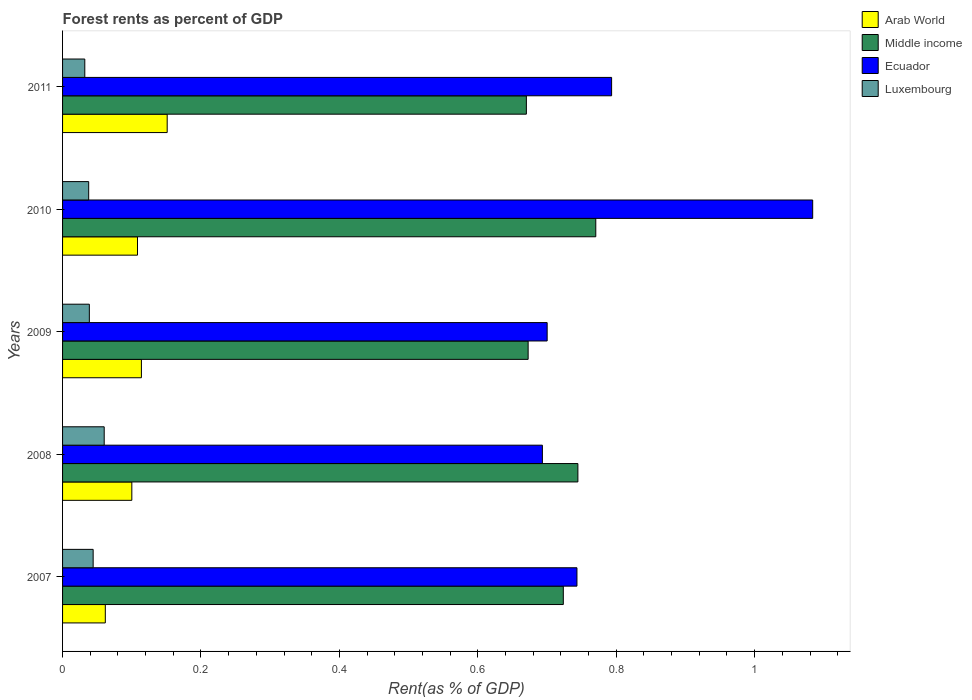How many different coloured bars are there?
Keep it short and to the point. 4. How many groups of bars are there?
Provide a short and direct response. 5. What is the label of the 4th group of bars from the top?
Provide a short and direct response. 2008. In how many cases, is the number of bars for a given year not equal to the number of legend labels?
Offer a very short reply. 0. What is the forest rent in Luxembourg in 2011?
Keep it short and to the point. 0.03. Across all years, what is the maximum forest rent in Middle income?
Your answer should be compact. 0.77. Across all years, what is the minimum forest rent in Arab World?
Provide a short and direct response. 0.06. In which year was the forest rent in Middle income maximum?
Provide a succinct answer. 2010. What is the total forest rent in Luxembourg in the graph?
Provide a succinct answer. 0.21. What is the difference between the forest rent in Luxembourg in 2007 and that in 2010?
Keep it short and to the point. 0.01. What is the difference between the forest rent in Arab World in 2009 and the forest rent in Luxembourg in 2008?
Ensure brevity in your answer.  0.05. What is the average forest rent in Arab World per year?
Your answer should be very brief. 0.11. In the year 2009, what is the difference between the forest rent in Middle income and forest rent in Luxembourg?
Offer a very short reply. 0.63. What is the ratio of the forest rent in Luxembourg in 2007 to that in 2009?
Your answer should be compact. 1.14. Is the forest rent in Ecuador in 2008 less than that in 2009?
Provide a short and direct response. Yes. What is the difference between the highest and the second highest forest rent in Ecuador?
Offer a very short reply. 0.29. What is the difference between the highest and the lowest forest rent in Luxembourg?
Give a very brief answer. 0.03. Is it the case that in every year, the sum of the forest rent in Ecuador and forest rent in Luxembourg is greater than the sum of forest rent in Arab World and forest rent in Middle income?
Give a very brief answer. Yes. What does the 4th bar from the top in 2008 represents?
Your answer should be very brief. Arab World. What does the 4th bar from the bottom in 2007 represents?
Give a very brief answer. Luxembourg. Does the graph contain any zero values?
Provide a short and direct response. No. Does the graph contain grids?
Give a very brief answer. No. What is the title of the graph?
Give a very brief answer. Forest rents as percent of GDP. Does "Brunei Darussalam" appear as one of the legend labels in the graph?
Your response must be concise. No. What is the label or title of the X-axis?
Keep it short and to the point. Rent(as % of GDP). What is the label or title of the Y-axis?
Give a very brief answer. Years. What is the Rent(as % of GDP) in Arab World in 2007?
Your response must be concise. 0.06. What is the Rent(as % of GDP) of Middle income in 2007?
Your response must be concise. 0.72. What is the Rent(as % of GDP) of Ecuador in 2007?
Ensure brevity in your answer.  0.74. What is the Rent(as % of GDP) of Luxembourg in 2007?
Your answer should be compact. 0.04. What is the Rent(as % of GDP) of Arab World in 2008?
Your response must be concise. 0.1. What is the Rent(as % of GDP) in Middle income in 2008?
Provide a succinct answer. 0.74. What is the Rent(as % of GDP) in Ecuador in 2008?
Offer a terse response. 0.69. What is the Rent(as % of GDP) in Luxembourg in 2008?
Make the answer very short. 0.06. What is the Rent(as % of GDP) in Arab World in 2009?
Ensure brevity in your answer.  0.11. What is the Rent(as % of GDP) of Middle income in 2009?
Your answer should be compact. 0.67. What is the Rent(as % of GDP) in Ecuador in 2009?
Make the answer very short. 0.7. What is the Rent(as % of GDP) in Luxembourg in 2009?
Give a very brief answer. 0.04. What is the Rent(as % of GDP) of Arab World in 2010?
Offer a terse response. 0.11. What is the Rent(as % of GDP) in Middle income in 2010?
Offer a very short reply. 0.77. What is the Rent(as % of GDP) in Ecuador in 2010?
Provide a short and direct response. 1.08. What is the Rent(as % of GDP) in Luxembourg in 2010?
Your answer should be compact. 0.04. What is the Rent(as % of GDP) of Arab World in 2011?
Your answer should be very brief. 0.15. What is the Rent(as % of GDP) of Middle income in 2011?
Offer a very short reply. 0.67. What is the Rent(as % of GDP) in Ecuador in 2011?
Provide a short and direct response. 0.79. What is the Rent(as % of GDP) of Luxembourg in 2011?
Your answer should be very brief. 0.03. Across all years, what is the maximum Rent(as % of GDP) in Arab World?
Provide a succinct answer. 0.15. Across all years, what is the maximum Rent(as % of GDP) in Middle income?
Offer a terse response. 0.77. Across all years, what is the maximum Rent(as % of GDP) in Ecuador?
Offer a very short reply. 1.08. Across all years, what is the maximum Rent(as % of GDP) of Luxembourg?
Provide a short and direct response. 0.06. Across all years, what is the minimum Rent(as % of GDP) in Arab World?
Make the answer very short. 0.06. Across all years, what is the minimum Rent(as % of GDP) in Middle income?
Your answer should be compact. 0.67. Across all years, what is the minimum Rent(as % of GDP) of Ecuador?
Give a very brief answer. 0.69. Across all years, what is the minimum Rent(as % of GDP) in Luxembourg?
Your response must be concise. 0.03. What is the total Rent(as % of GDP) in Arab World in the graph?
Provide a short and direct response. 0.54. What is the total Rent(as % of GDP) in Middle income in the graph?
Provide a succinct answer. 3.58. What is the total Rent(as % of GDP) of Ecuador in the graph?
Provide a succinct answer. 4.01. What is the total Rent(as % of GDP) in Luxembourg in the graph?
Keep it short and to the point. 0.21. What is the difference between the Rent(as % of GDP) of Arab World in 2007 and that in 2008?
Make the answer very short. -0.04. What is the difference between the Rent(as % of GDP) in Middle income in 2007 and that in 2008?
Offer a terse response. -0.02. What is the difference between the Rent(as % of GDP) in Ecuador in 2007 and that in 2008?
Your answer should be very brief. 0.05. What is the difference between the Rent(as % of GDP) of Luxembourg in 2007 and that in 2008?
Keep it short and to the point. -0.02. What is the difference between the Rent(as % of GDP) of Arab World in 2007 and that in 2009?
Keep it short and to the point. -0.05. What is the difference between the Rent(as % of GDP) of Middle income in 2007 and that in 2009?
Provide a succinct answer. 0.05. What is the difference between the Rent(as % of GDP) in Ecuador in 2007 and that in 2009?
Your response must be concise. 0.04. What is the difference between the Rent(as % of GDP) in Luxembourg in 2007 and that in 2009?
Offer a very short reply. 0.01. What is the difference between the Rent(as % of GDP) of Arab World in 2007 and that in 2010?
Keep it short and to the point. -0.05. What is the difference between the Rent(as % of GDP) in Middle income in 2007 and that in 2010?
Ensure brevity in your answer.  -0.05. What is the difference between the Rent(as % of GDP) of Ecuador in 2007 and that in 2010?
Ensure brevity in your answer.  -0.34. What is the difference between the Rent(as % of GDP) of Luxembourg in 2007 and that in 2010?
Ensure brevity in your answer.  0.01. What is the difference between the Rent(as % of GDP) in Arab World in 2007 and that in 2011?
Ensure brevity in your answer.  -0.09. What is the difference between the Rent(as % of GDP) of Middle income in 2007 and that in 2011?
Offer a terse response. 0.05. What is the difference between the Rent(as % of GDP) in Ecuador in 2007 and that in 2011?
Keep it short and to the point. -0.05. What is the difference between the Rent(as % of GDP) of Luxembourg in 2007 and that in 2011?
Ensure brevity in your answer.  0.01. What is the difference between the Rent(as % of GDP) in Arab World in 2008 and that in 2009?
Offer a very short reply. -0.01. What is the difference between the Rent(as % of GDP) of Middle income in 2008 and that in 2009?
Provide a short and direct response. 0.07. What is the difference between the Rent(as % of GDP) in Ecuador in 2008 and that in 2009?
Provide a short and direct response. -0.01. What is the difference between the Rent(as % of GDP) of Luxembourg in 2008 and that in 2009?
Make the answer very short. 0.02. What is the difference between the Rent(as % of GDP) in Arab World in 2008 and that in 2010?
Your answer should be compact. -0.01. What is the difference between the Rent(as % of GDP) in Middle income in 2008 and that in 2010?
Offer a very short reply. -0.03. What is the difference between the Rent(as % of GDP) of Ecuador in 2008 and that in 2010?
Your answer should be compact. -0.39. What is the difference between the Rent(as % of GDP) of Luxembourg in 2008 and that in 2010?
Your answer should be very brief. 0.02. What is the difference between the Rent(as % of GDP) in Arab World in 2008 and that in 2011?
Provide a succinct answer. -0.05. What is the difference between the Rent(as % of GDP) in Middle income in 2008 and that in 2011?
Your answer should be very brief. 0.07. What is the difference between the Rent(as % of GDP) in Luxembourg in 2008 and that in 2011?
Ensure brevity in your answer.  0.03. What is the difference between the Rent(as % of GDP) in Arab World in 2009 and that in 2010?
Your answer should be very brief. 0.01. What is the difference between the Rent(as % of GDP) in Middle income in 2009 and that in 2010?
Your response must be concise. -0.1. What is the difference between the Rent(as % of GDP) in Ecuador in 2009 and that in 2010?
Keep it short and to the point. -0.38. What is the difference between the Rent(as % of GDP) of Luxembourg in 2009 and that in 2010?
Give a very brief answer. 0. What is the difference between the Rent(as % of GDP) of Arab World in 2009 and that in 2011?
Offer a terse response. -0.04. What is the difference between the Rent(as % of GDP) in Middle income in 2009 and that in 2011?
Ensure brevity in your answer.  0. What is the difference between the Rent(as % of GDP) of Ecuador in 2009 and that in 2011?
Offer a terse response. -0.09. What is the difference between the Rent(as % of GDP) of Luxembourg in 2009 and that in 2011?
Provide a short and direct response. 0.01. What is the difference between the Rent(as % of GDP) of Arab World in 2010 and that in 2011?
Keep it short and to the point. -0.04. What is the difference between the Rent(as % of GDP) in Middle income in 2010 and that in 2011?
Your answer should be very brief. 0.1. What is the difference between the Rent(as % of GDP) of Ecuador in 2010 and that in 2011?
Ensure brevity in your answer.  0.29. What is the difference between the Rent(as % of GDP) in Luxembourg in 2010 and that in 2011?
Your answer should be compact. 0.01. What is the difference between the Rent(as % of GDP) in Arab World in 2007 and the Rent(as % of GDP) in Middle income in 2008?
Keep it short and to the point. -0.68. What is the difference between the Rent(as % of GDP) in Arab World in 2007 and the Rent(as % of GDP) in Ecuador in 2008?
Your response must be concise. -0.63. What is the difference between the Rent(as % of GDP) in Arab World in 2007 and the Rent(as % of GDP) in Luxembourg in 2008?
Offer a very short reply. 0. What is the difference between the Rent(as % of GDP) in Middle income in 2007 and the Rent(as % of GDP) in Ecuador in 2008?
Provide a succinct answer. 0.03. What is the difference between the Rent(as % of GDP) in Middle income in 2007 and the Rent(as % of GDP) in Luxembourg in 2008?
Your answer should be compact. 0.66. What is the difference between the Rent(as % of GDP) in Ecuador in 2007 and the Rent(as % of GDP) in Luxembourg in 2008?
Provide a short and direct response. 0.68. What is the difference between the Rent(as % of GDP) in Arab World in 2007 and the Rent(as % of GDP) in Middle income in 2009?
Make the answer very short. -0.61. What is the difference between the Rent(as % of GDP) in Arab World in 2007 and the Rent(as % of GDP) in Ecuador in 2009?
Your answer should be very brief. -0.64. What is the difference between the Rent(as % of GDP) of Arab World in 2007 and the Rent(as % of GDP) of Luxembourg in 2009?
Keep it short and to the point. 0.02. What is the difference between the Rent(as % of GDP) in Middle income in 2007 and the Rent(as % of GDP) in Ecuador in 2009?
Make the answer very short. 0.02. What is the difference between the Rent(as % of GDP) in Middle income in 2007 and the Rent(as % of GDP) in Luxembourg in 2009?
Provide a succinct answer. 0.68. What is the difference between the Rent(as % of GDP) of Ecuador in 2007 and the Rent(as % of GDP) of Luxembourg in 2009?
Provide a succinct answer. 0.7. What is the difference between the Rent(as % of GDP) in Arab World in 2007 and the Rent(as % of GDP) in Middle income in 2010?
Your response must be concise. -0.71. What is the difference between the Rent(as % of GDP) in Arab World in 2007 and the Rent(as % of GDP) in Ecuador in 2010?
Make the answer very short. -1.02. What is the difference between the Rent(as % of GDP) in Arab World in 2007 and the Rent(as % of GDP) in Luxembourg in 2010?
Ensure brevity in your answer.  0.02. What is the difference between the Rent(as % of GDP) in Middle income in 2007 and the Rent(as % of GDP) in Ecuador in 2010?
Your response must be concise. -0.36. What is the difference between the Rent(as % of GDP) in Middle income in 2007 and the Rent(as % of GDP) in Luxembourg in 2010?
Offer a terse response. 0.69. What is the difference between the Rent(as % of GDP) in Ecuador in 2007 and the Rent(as % of GDP) in Luxembourg in 2010?
Keep it short and to the point. 0.71. What is the difference between the Rent(as % of GDP) in Arab World in 2007 and the Rent(as % of GDP) in Middle income in 2011?
Provide a succinct answer. -0.61. What is the difference between the Rent(as % of GDP) in Arab World in 2007 and the Rent(as % of GDP) in Ecuador in 2011?
Offer a very short reply. -0.73. What is the difference between the Rent(as % of GDP) of Arab World in 2007 and the Rent(as % of GDP) of Luxembourg in 2011?
Provide a short and direct response. 0.03. What is the difference between the Rent(as % of GDP) of Middle income in 2007 and the Rent(as % of GDP) of Ecuador in 2011?
Give a very brief answer. -0.07. What is the difference between the Rent(as % of GDP) of Middle income in 2007 and the Rent(as % of GDP) of Luxembourg in 2011?
Your answer should be very brief. 0.69. What is the difference between the Rent(as % of GDP) of Ecuador in 2007 and the Rent(as % of GDP) of Luxembourg in 2011?
Offer a terse response. 0.71. What is the difference between the Rent(as % of GDP) in Arab World in 2008 and the Rent(as % of GDP) in Middle income in 2009?
Offer a very short reply. -0.57. What is the difference between the Rent(as % of GDP) of Arab World in 2008 and the Rent(as % of GDP) of Ecuador in 2009?
Provide a succinct answer. -0.6. What is the difference between the Rent(as % of GDP) in Arab World in 2008 and the Rent(as % of GDP) in Luxembourg in 2009?
Make the answer very short. 0.06. What is the difference between the Rent(as % of GDP) in Middle income in 2008 and the Rent(as % of GDP) in Ecuador in 2009?
Offer a terse response. 0.04. What is the difference between the Rent(as % of GDP) of Middle income in 2008 and the Rent(as % of GDP) of Luxembourg in 2009?
Offer a very short reply. 0.71. What is the difference between the Rent(as % of GDP) in Ecuador in 2008 and the Rent(as % of GDP) in Luxembourg in 2009?
Your answer should be very brief. 0.65. What is the difference between the Rent(as % of GDP) in Arab World in 2008 and the Rent(as % of GDP) in Middle income in 2010?
Provide a short and direct response. -0.67. What is the difference between the Rent(as % of GDP) in Arab World in 2008 and the Rent(as % of GDP) in Ecuador in 2010?
Your answer should be very brief. -0.98. What is the difference between the Rent(as % of GDP) in Arab World in 2008 and the Rent(as % of GDP) in Luxembourg in 2010?
Offer a very short reply. 0.06. What is the difference between the Rent(as % of GDP) of Middle income in 2008 and the Rent(as % of GDP) of Ecuador in 2010?
Give a very brief answer. -0.34. What is the difference between the Rent(as % of GDP) of Middle income in 2008 and the Rent(as % of GDP) of Luxembourg in 2010?
Offer a terse response. 0.71. What is the difference between the Rent(as % of GDP) of Ecuador in 2008 and the Rent(as % of GDP) of Luxembourg in 2010?
Ensure brevity in your answer.  0.66. What is the difference between the Rent(as % of GDP) of Arab World in 2008 and the Rent(as % of GDP) of Middle income in 2011?
Keep it short and to the point. -0.57. What is the difference between the Rent(as % of GDP) in Arab World in 2008 and the Rent(as % of GDP) in Ecuador in 2011?
Offer a very short reply. -0.69. What is the difference between the Rent(as % of GDP) in Arab World in 2008 and the Rent(as % of GDP) in Luxembourg in 2011?
Your answer should be compact. 0.07. What is the difference between the Rent(as % of GDP) of Middle income in 2008 and the Rent(as % of GDP) of Ecuador in 2011?
Offer a terse response. -0.05. What is the difference between the Rent(as % of GDP) in Middle income in 2008 and the Rent(as % of GDP) in Luxembourg in 2011?
Offer a very short reply. 0.71. What is the difference between the Rent(as % of GDP) of Ecuador in 2008 and the Rent(as % of GDP) of Luxembourg in 2011?
Make the answer very short. 0.66. What is the difference between the Rent(as % of GDP) of Arab World in 2009 and the Rent(as % of GDP) of Middle income in 2010?
Your response must be concise. -0.66. What is the difference between the Rent(as % of GDP) in Arab World in 2009 and the Rent(as % of GDP) in Ecuador in 2010?
Your answer should be very brief. -0.97. What is the difference between the Rent(as % of GDP) in Arab World in 2009 and the Rent(as % of GDP) in Luxembourg in 2010?
Give a very brief answer. 0.08. What is the difference between the Rent(as % of GDP) in Middle income in 2009 and the Rent(as % of GDP) in Ecuador in 2010?
Keep it short and to the point. -0.41. What is the difference between the Rent(as % of GDP) in Middle income in 2009 and the Rent(as % of GDP) in Luxembourg in 2010?
Provide a succinct answer. 0.63. What is the difference between the Rent(as % of GDP) in Ecuador in 2009 and the Rent(as % of GDP) in Luxembourg in 2010?
Give a very brief answer. 0.66. What is the difference between the Rent(as % of GDP) of Arab World in 2009 and the Rent(as % of GDP) of Middle income in 2011?
Provide a short and direct response. -0.56. What is the difference between the Rent(as % of GDP) of Arab World in 2009 and the Rent(as % of GDP) of Ecuador in 2011?
Offer a terse response. -0.68. What is the difference between the Rent(as % of GDP) in Arab World in 2009 and the Rent(as % of GDP) in Luxembourg in 2011?
Keep it short and to the point. 0.08. What is the difference between the Rent(as % of GDP) in Middle income in 2009 and the Rent(as % of GDP) in Ecuador in 2011?
Keep it short and to the point. -0.12. What is the difference between the Rent(as % of GDP) in Middle income in 2009 and the Rent(as % of GDP) in Luxembourg in 2011?
Offer a terse response. 0.64. What is the difference between the Rent(as % of GDP) in Ecuador in 2009 and the Rent(as % of GDP) in Luxembourg in 2011?
Provide a succinct answer. 0.67. What is the difference between the Rent(as % of GDP) of Arab World in 2010 and the Rent(as % of GDP) of Middle income in 2011?
Offer a terse response. -0.56. What is the difference between the Rent(as % of GDP) of Arab World in 2010 and the Rent(as % of GDP) of Ecuador in 2011?
Provide a short and direct response. -0.69. What is the difference between the Rent(as % of GDP) in Arab World in 2010 and the Rent(as % of GDP) in Luxembourg in 2011?
Offer a terse response. 0.08. What is the difference between the Rent(as % of GDP) of Middle income in 2010 and the Rent(as % of GDP) of Ecuador in 2011?
Make the answer very short. -0.02. What is the difference between the Rent(as % of GDP) of Middle income in 2010 and the Rent(as % of GDP) of Luxembourg in 2011?
Give a very brief answer. 0.74. What is the difference between the Rent(as % of GDP) in Ecuador in 2010 and the Rent(as % of GDP) in Luxembourg in 2011?
Make the answer very short. 1.05. What is the average Rent(as % of GDP) of Arab World per year?
Ensure brevity in your answer.  0.11. What is the average Rent(as % of GDP) in Middle income per year?
Give a very brief answer. 0.72. What is the average Rent(as % of GDP) in Ecuador per year?
Provide a short and direct response. 0.8. What is the average Rent(as % of GDP) in Luxembourg per year?
Ensure brevity in your answer.  0.04. In the year 2007, what is the difference between the Rent(as % of GDP) in Arab World and Rent(as % of GDP) in Middle income?
Your response must be concise. -0.66. In the year 2007, what is the difference between the Rent(as % of GDP) in Arab World and Rent(as % of GDP) in Ecuador?
Your answer should be very brief. -0.68. In the year 2007, what is the difference between the Rent(as % of GDP) of Arab World and Rent(as % of GDP) of Luxembourg?
Give a very brief answer. 0.02. In the year 2007, what is the difference between the Rent(as % of GDP) of Middle income and Rent(as % of GDP) of Ecuador?
Your answer should be compact. -0.02. In the year 2007, what is the difference between the Rent(as % of GDP) of Middle income and Rent(as % of GDP) of Luxembourg?
Your answer should be compact. 0.68. In the year 2007, what is the difference between the Rent(as % of GDP) of Ecuador and Rent(as % of GDP) of Luxembourg?
Your answer should be very brief. 0.7. In the year 2008, what is the difference between the Rent(as % of GDP) in Arab World and Rent(as % of GDP) in Middle income?
Make the answer very short. -0.64. In the year 2008, what is the difference between the Rent(as % of GDP) of Arab World and Rent(as % of GDP) of Ecuador?
Make the answer very short. -0.59. In the year 2008, what is the difference between the Rent(as % of GDP) in Arab World and Rent(as % of GDP) in Luxembourg?
Your answer should be very brief. 0.04. In the year 2008, what is the difference between the Rent(as % of GDP) of Middle income and Rent(as % of GDP) of Ecuador?
Ensure brevity in your answer.  0.05. In the year 2008, what is the difference between the Rent(as % of GDP) in Middle income and Rent(as % of GDP) in Luxembourg?
Your answer should be compact. 0.68. In the year 2008, what is the difference between the Rent(as % of GDP) of Ecuador and Rent(as % of GDP) of Luxembourg?
Ensure brevity in your answer.  0.63. In the year 2009, what is the difference between the Rent(as % of GDP) in Arab World and Rent(as % of GDP) in Middle income?
Provide a short and direct response. -0.56. In the year 2009, what is the difference between the Rent(as % of GDP) in Arab World and Rent(as % of GDP) in Ecuador?
Your answer should be compact. -0.59. In the year 2009, what is the difference between the Rent(as % of GDP) of Arab World and Rent(as % of GDP) of Luxembourg?
Make the answer very short. 0.08. In the year 2009, what is the difference between the Rent(as % of GDP) in Middle income and Rent(as % of GDP) in Ecuador?
Give a very brief answer. -0.03. In the year 2009, what is the difference between the Rent(as % of GDP) in Middle income and Rent(as % of GDP) in Luxembourg?
Give a very brief answer. 0.63. In the year 2009, what is the difference between the Rent(as % of GDP) of Ecuador and Rent(as % of GDP) of Luxembourg?
Your answer should be very brief. 0.66. In the year 2010, what is the difference between the Rent(as % of GDP) of Arab World and Rent(as % of GDP) of Middle income?
Keep it short and to the point. -0.66. In the year 2010, what is the difference between the Rent(as % of GDP) in Arab World and Rent(as % of GDP) in Ecuador?
Keep it short and to the point. -0.98. In the year 2010, what is the difference between the Rent(as % of GDP) in Arab World and Rent(as % of GDP) in Luxembourg?
Provide a succinct answer. 0.07. In the year 2010, what is the difference between the Rent(as % of GDP) in Middle income and Rent(as % of GDP) in Ecuador?
Your response must be concise. -0.31. In the year 2010, what is the difference between the Rent(as % of GDP) in Middle income and Rent(as % of GDP) in Luxembourg?
Make the answer very short. 0.73. In the year 2010, what is the difference between the Rent(as % of GDP) of Ecuador and Rent(as % of GDP) of Luxembourg?
Your answer should be compact. 1.05. In the year 2011, what is the difference between the Rent(as % of GDP) in Arab World and Rent(as % of GDP) in Middle income?
Make the answer very short. -0.52. In the year 2011, what is the difference between the Rent(as % of GDP) of Arab World and Rent(as % of GDP) of Ecuador?
Your answer should be very brief. -0.64. In the year 2011, what is the difference between the Rent(as % of GDP) in Arab World and Rent(as % of GDP) in Luxembourg?
Make the answer very short. 0.12. In the year 2011, what is the difference between the Rent(as % of GDP) in Middle income and Rent(as % of GDP) in Ecuador?
Provide a succinct answer. -0.12. In the year 2011, what is the difference between the Rent(as % of GDP) of Middle income and Rent(as % of GDP) of Luxembourg?
Offer a very short reply. 0.64. In the year 2011, what is the difference between the Rent(as % of GDP) of Ecuador and Rent(as % of GDP) of Luxembourg?
Your answer should be very brief. 0.76. What is the ratio of the Rent(as % of GDP) of Arab World in 2007 to that in 2008?
Your answer should be very brief. 0.62. What is the ratio of the Rent(as % of GDP) of Middle income in 2007 to that in 2008?
Ensure brevity in your answer.  0.97. What is the ratio of the Rent(as % of GDP) in Ecuador in 2007 to that in 2008?
Provide a succinct answer. 1.07. What is the ratio of the Rent(as % of GDP) of Luxembourg in 2007 to that in 2008?
Give a very brief answer. 0.73. What is the ratio of the Rent(as % of GDP) in Arab World in 2007 to that in 2009?
Your answer should be compact. 0.54. What is the ratio of the Rent(as % of GDP) of Middle income in 2007 to that in 2009?
Offer a very short reply. 1.08. What is the ratio of the Rent(as % of GDP) of Ecuador in 2007 to that in 2009?
Keep it short and to the point. 1.06. What is the ratio of the Rent(as % of GDP) of Luxembourg in 2007 to that in 2009?
Your answer should be compact. 1.14. What is the ratio of the Rent(as % of GDP) of Arab World in 2007 to that in 2010?
Ensure brevity in your answer.  0.57. What is the ratio of the Rent(as % of GDP) in Middle income in 2007 to that in 2010?
Provide a short and direct response. 0.94. What is the ratio of the Rent(as % of GDP) of Ecuador in 2007 to that in 2010?
Provide a succinct answer. 0.69. What is the ratio of the Rent(as % of GDP) in Luxembourg in 2007 to that in 2010?
Your answer should be very brief. 1.17. What is the ratio of the Rent(as % of GDP) of Arab World in 2007 to that in 2011?
Offer a very short reply. 0.41. What is the ratio of the Rent(as % of GDP) in Middle income in 2007 to that in 2011?
Your answer should be very brief. 1.08. What is the ratio of the Rent(as % of GDP) of Ecuador in 2007 to that in 2011?
Provide a succinct answer. 0.94. What is the ratio of the Rent(as % of GDP) of Luxembourg in 2007 to that in 2011?
Give a very brief answer. 1.38. What is the ratio of the Rent(as % of GDP) in Arab World in 2008 to that in 2009?
Offer a terse response. 0.88. What is the ratio of the Rent(as % of GDP) in Middle income in 2008 to that in 2009?
Make the answer very short. 1.11. What is the ratio of the Rent(as % of GDP) in Ecuador in 2008 to that in 2009?
Give a very brief answer. 0.99. What is the ratio of the Rent(as % of GDP) in Luxembourg in 2008 to that in 2009?
Your answer should be compact. 1.56. What is the ratio of the Rent(as % of GDP) of Arab World in 2008 to that in 2010?
Your answer should be very brief. 0.92. What is the ratio of the Rent(as % of GDP) of Middle income in 2008 to that in 2010?
Give a very brief answer. 0.97. What is the ratio of the Rent(as % of GDP) in Ecuador in 2008 to that in 2010?
Offer a terse response. 0.64. What is the ratio of the Rent(as % of GDP) in Luxembourg in 2008 to that in 2010?
Offer a very short reply. 1.59. What is the ratio of the Rent(as % of GDP) of Arab World in 2008 to that in 2011?
Make the answer very short. 0.66. What is the ratio of the Rent(as % of GDP) of Middle income in 2008 to that in 2011?
Keep it short and to the point. 1.11. What is the ratio of the Rent(as % of GDP) of Ecuador in 2008 to that in 2011?
Ensure brevity in your answer.  0.87. What is the ratio of the Rent(as % of GDP) of Luxembourg in 2008 to that in 2011?
Your answer should be very brief. 1.87. What is the ratio of the Rent(as % of GDP) of Arab World in 2009 to that in 2010?
Provide a short and direct response. 1.05. What is the ratio of the Rent(as % of GDP) in Middle income in 2009 to that in 2010?
Provide a succinct answer. 0.87. What is the ratio of the Rent(as % of GDP) in Ecuador in 2009 to that in 2010?
Offer a terse response. 0.65. What is the ratio of the Rent(as % of GDP) of Luxembourg in 2009 to that in 2010?
Ensure brevity in your answer.  1.03. What is the ratio of the Rent(as % of GDP) of Arab World in 2009 to that in 2011?
Make the answer very short. 0.75. What is the ratio of the Rent(as % of GDP) of Middle income in 2009 to that in 2011?
Your response must be concise. 1. What is the ratio of the Rent(as % of GDP) of Ecuador in 2009 to that in 2011?
Make the answer very short. 0.88. What is the ratio of the Rent(as % of GDP) of Luxembourg in 2009 to that in 2011?
Offer a terse response. 1.2. What is the ratio of the Rent(as % of GDP) of Arab World in 2010 to that in 2011?
Provide a succinct answer. 0.72. What is the ratio of the Rent(as % of GDP) of Middle income in 2010 to that in 2011?
Provide a succinct answer. 1.15. What is the ratio of the Rent(as % of GDP) in Ecuador in 2010 to that in 2011?
Provide a succinct answer. 1.37. What is the ratio of the Rent(as % of GDP) in Luxembourg in 2010 to that in 2011?
Provide a succinct answer. 1.17. What is the difference between the highest and the second highest Rent(as % of GDP) of Arab World?
Provide a succinct answer. 0.04. What is the difference between the highest and the second highest Rent(as % of GDP) in Middle income?
Your answer should be very brief. 0.03. What is the difference between the highest and the second highest Rent(as % of GDP) in Ecuador?
Provide a short and direct response. 0.29. What is the difference between the highest and the second highest Rent(as % of GDP) in Luxembourg?
Your answer should be very brief. 0.02. What is the difference between the highest and the lowest Rent(as % of GDP) of Arab World?
Provide a succinct answer. 0.09. What is the difference between the highest and the lowest Rent(as % of GDP) of Middle income?
Provide a succinct answer. 0.1. What is the difference between the highest and the lowest Rent(as % of GDP) in Ecuador?
Provide a short and direct response. 0.39. What is the difference between the highest and the lowest Rent(as % of GDP) of Luxembourg?
Keep it short and to the point. 0.03. 